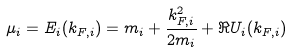Convert formula to latex. <formula><loc_0><loc_0><loc_500><loc_500>\mu _ { i } = E _ { i } ( k _ { F , i } ) = m _ { i } + \frac { k _ { F , i } ^ { 2 } } { 2 m _ { i } } + \Re U _ { i } ( k _ { F , i } )</formula> 